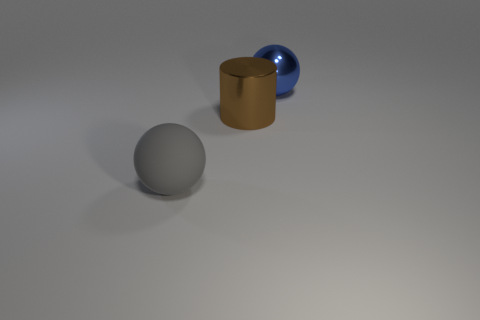Add 3 small brown shiny blocks. How many objects exist? 6 Subtract all gray spheres. How many spheres are left? 1 Subtract 1 spheres. How many spheres are left? 1 Subtract 0 purple spheres. How many objects are left? 3 Subtract all cylinders. How many objects are left? 2 Subtract all yellow cylinders. Subtract all red balls. How many cylinders are left? 1 Subtract all gray blocks. How many green cylinders are left? 0 Subtract all large spheres. Subtract all big brown matte spheres. How many objects are left? 1 Add 1 large gray balls. How many large gray balls are left? 2 Add 1 big red cubes. How many big red cubes exist? 1 